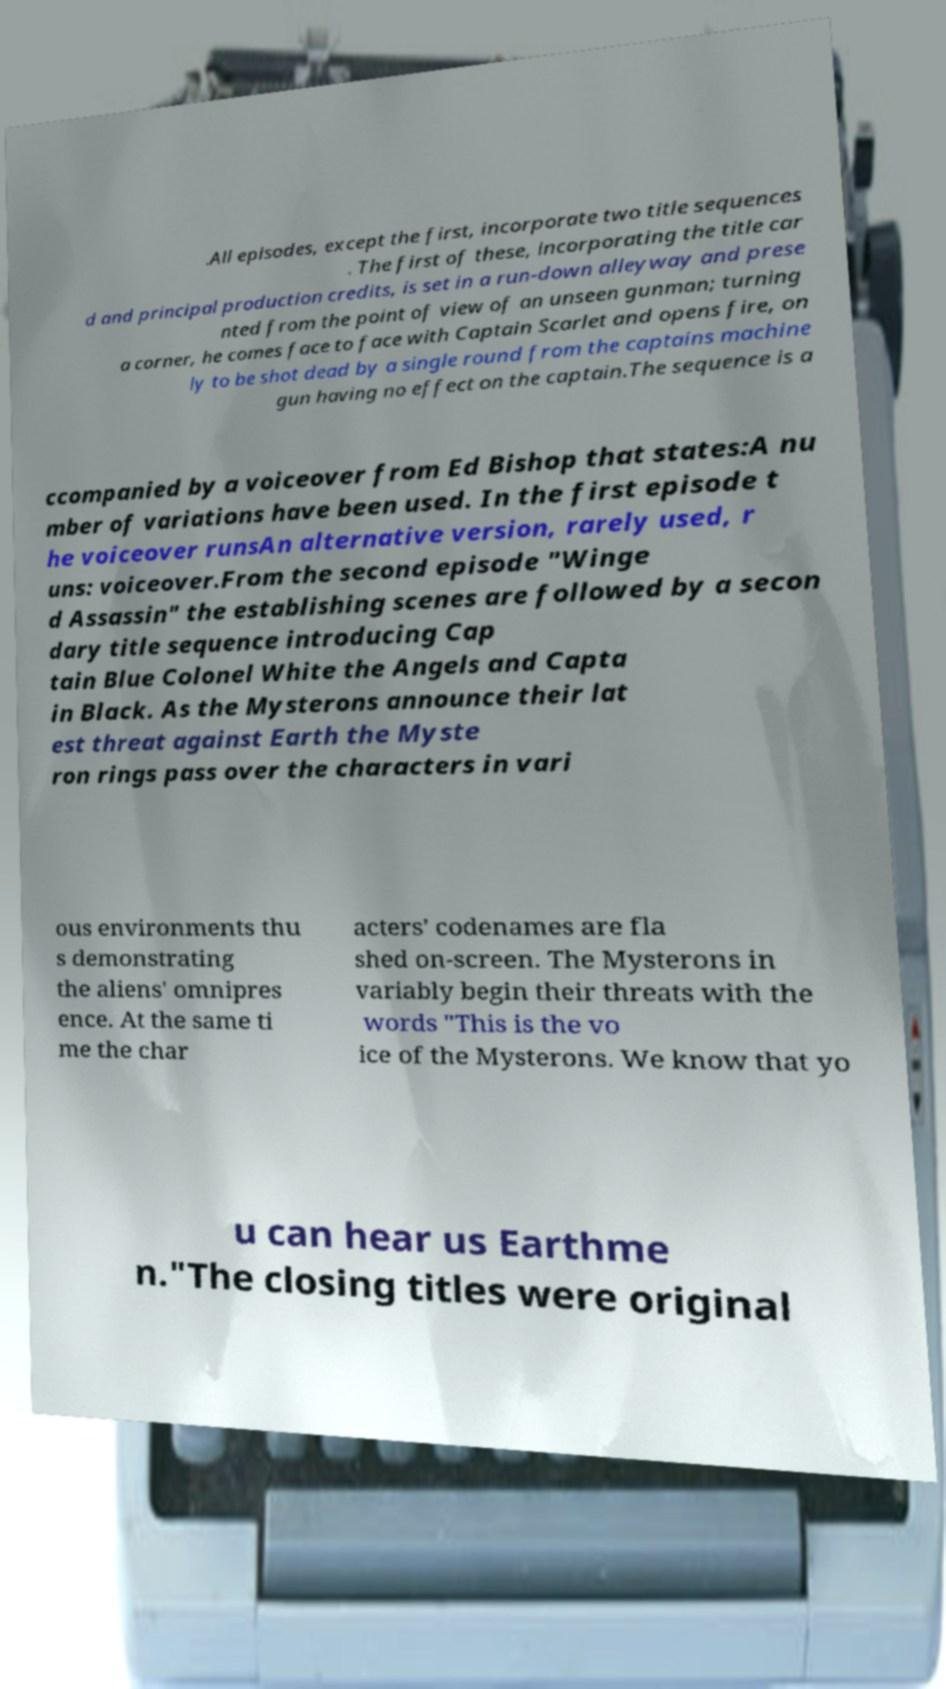Please read and relay the text visible in this image. What does it say? .All episodes, except the first, incorporate two title sequences . The first of these, incorporating the title car d and principal production credits, is set in a run-down alleyway and prese nted from the point of view of an unseen gunman; turning a corner, he comes face to face with Captain Scarlet and opens fire, on ly to be shot dead by a single round from the captains machine gun having no effect on the captain.The sequence is a ccompanied by a voiceover from Ed Bishop that states:A nu mber of variations have been used. In the first episode t he voiceover runsAn alternative version, rarely used, r uns: voiceover.From the second episode "Winge d Assassin" the establishing scenes are followed by a secon dary title sequence introducing Cap tain Blue Colonel White the Angels and Capta in Black. As the Mysterons announce their lat est threat against Earth the Myste ron rings pass over the characters in vari ous environments thu s demonstrating the aliens' omnipres ence. At the same ti me the char acters' codenames are fla shed on-screen. The Mysterons in variably begin their threats with the words "This is the vo ice of the Mysterons. We know that yo u can hear us Earthme n."The closing titles were original 